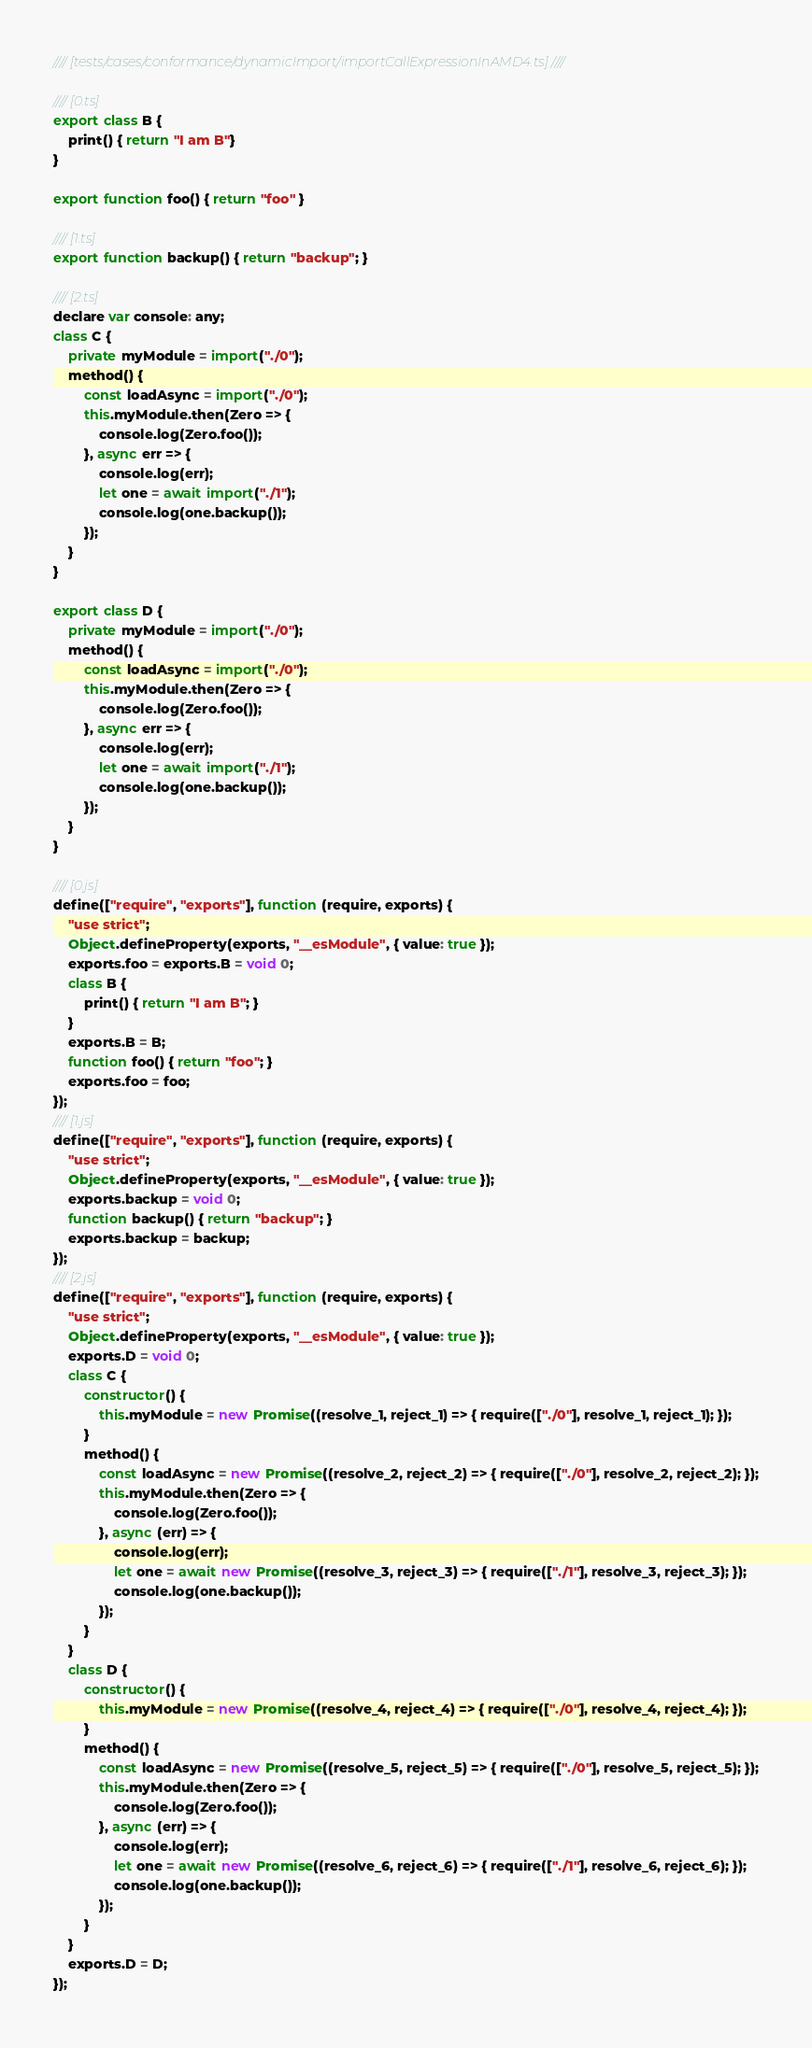Convert code to text. <code><loc_0><loc_0><loc_500><loc_500><_JavaScript_>//// [tests/cases/conformance/dynamicImport/importCallExpressionInAMD4.ts] ////

//// [0.ts]
export class B {
    print() { return "I am B"}
}

export function foo() { return "foo" }

//// [1.ts]
export function backup() { return "backup"; }

//// [2.ts]
declare var console: any;
class C {
    private myModule = import("./0");
    method() {
        const loadAsync = import("./0");
        this.myModule.then(Zero => {
            console.log(Zero.foo());
        }, async err => {
            console.log(err);
            let one = await import("./1");
            console.log(one.backup());
        });
    }
}

export class D {
    private myModule = import("./0");
    method() {
        const loadAsync = import("./0");
        this.myModule.then(Zero => {
            console.log(Zero.foo());
        }, async err => {
            console.log(err);
            let one = await import("./1");
            console.log(one.backup());
        });
    }
}

//// [0.js]
define(["require", "exports"], function (require, exports) {
    "use strict";
    Object.defineProperty(exports, "__esModule", { value: true });
    exports.foo = exports.B = void 0;
    class B {
        print() { return "I am B"; }
    }
    exports.B = B;
    function foo() { return "foo"; }
    exports.foo = foo;
});
//// [1.js]
define(["require", "exports"], function (require, exports) {
    "use strict";
    Object.defineProperty(exports, "__esModule", { value: true });
    exports.backup = void 0;
    function backup() { return "backup"; }
    exports.backup = backup;
});
//// [2.js]
define(["require", "exports"], function (require, exports) {
    "use strict";
    Object.defineProperty(exports, "__esModule", { value: true });
    exports.D = void 0;
    class C {
        constructor() {
            this.myModule = new Promise((resolve_1, reject_1) => { require(["./0"], resolve_1, reject_1); });
        }
        method() {
            const loadAsync = new Promise((resolve_2, reject_2) => { require(["./0"], resolve_2, reject_2); });
            this.myModule.then(Zero => {
                console.log(Zero.foo());
            }, async (err) => {
                console.log(err);
                let one = await new Promise((resolve_3, reject_3) => { require(["./1"], resolve_3, reject_3); });
                console.log(one.backup());
            });
        }
    }
    class D {
        constructor() {
            this.myModule = new Promise((resolve_4, reject_4) => { require(["./0"], resolve_4, reject_4); });
        }
        method() {
            const loadAsync = new Promise((resolve_5, reject_5) => { require(["./0"], resolve_5, reject_5); });
            this.myModule.then(Zero => {
                console.log(Zero.foo());
            }, async (err) => {
                console.log(err);
                let one = await new Promise((resolve_6, reject_6) => { require(["./1"], resolve_6, reject_6); });
                console.log(one.backup());
            });
        }
    }
    exports.D = D;
});
</code> 